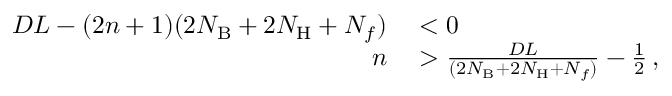<formula> <loc_0><loc_0><loc_500><loc_500>\begin{array} { r l } { D L - ( 2 n + 1 ) ( 2 N _ { B } + 2 N _ { H } + N _ { f } ) } & < 0 } \\ { n } & > \frac { D L } { ( 2 N _ { B } + 2 N _ { H } + N _ { f } ) } - \frac { 1 } { 2 } \, , } \end{array}</formula> 